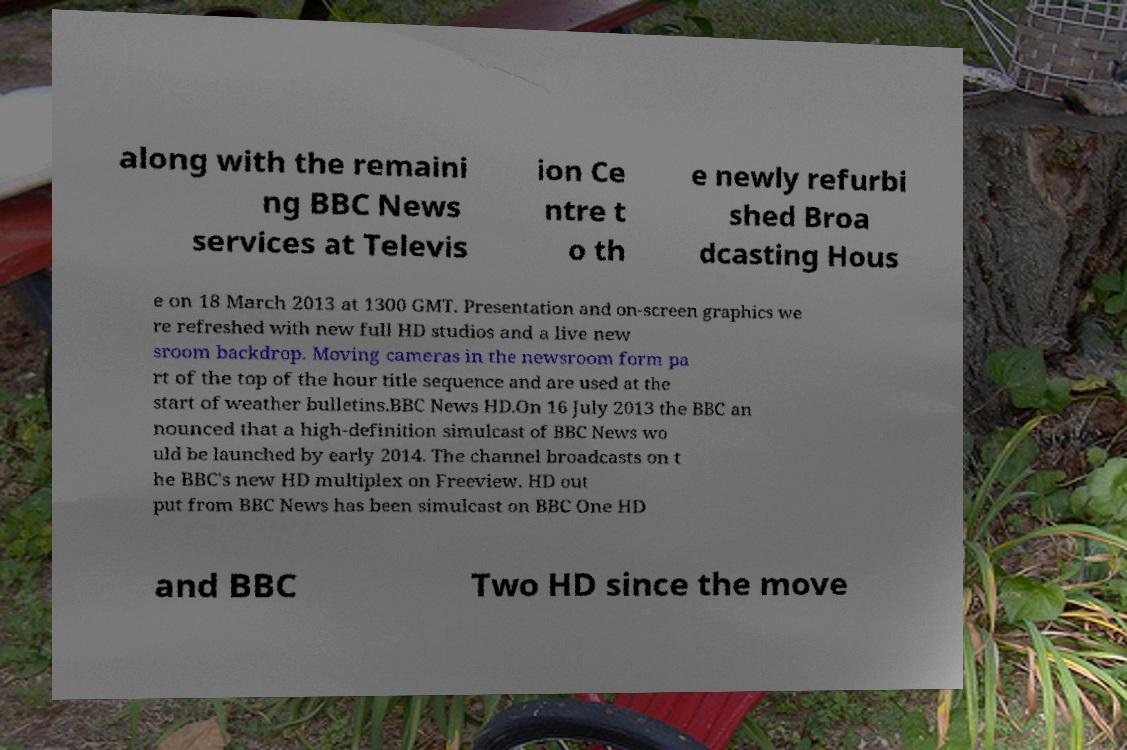I need the written content from this picture converted into text. Can you do that? along with the remaini ng BBC News services at Televis ion Ce ntre t o th e newly refurbi shed Broa dcasting Hous e on 18 March 2013 at 1300 GMT. Presentation and on-screen graphics we re refreshed with new full HD studios and a live new sroom backdrop. Moving cameras in the newsroom form pa rt of the top of the hour title sequence and are used at the start of weather bulletins.BBC News HD.On 16 July 2013 the BBC an nounced that a high-definition simulcast of BBC News wo uld be launched by early 2014. The channel broadcasts on t he BBC's new HD multiplex on Freeview. HD out put from BBC News has been simulcast on BBC One HD and BBC Two HD since the move 